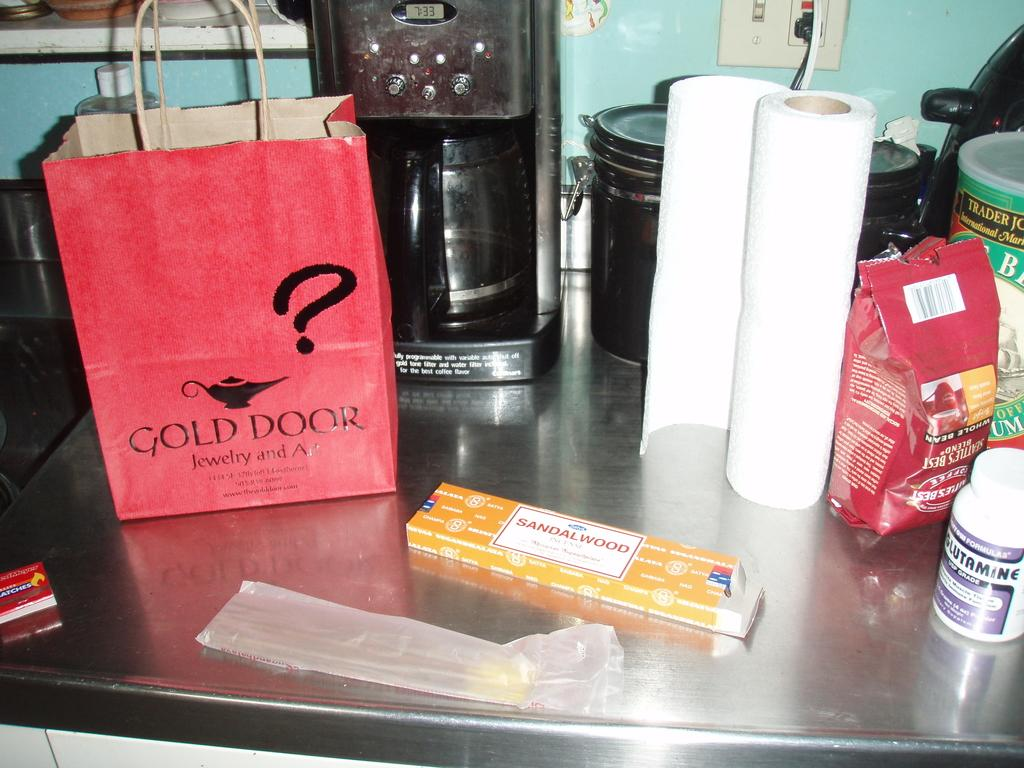<image>
Present a compact description of the photo's key features. A red bag labeled GOld Door is sitting on a kitchen counter. 